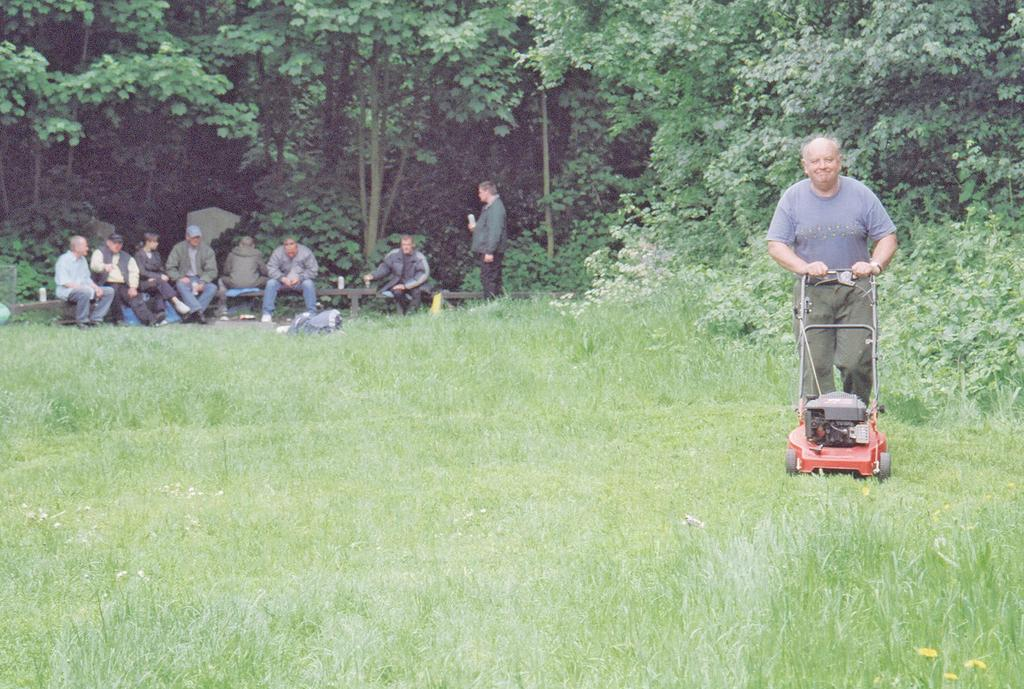How many people are in the image? There are people in the image, but the exact number is not specified. What is one person doing in the image? One person is holding a machine in the image. What can be seen under the people's feet? The ground is visible in the image, and there is grass on the ground. What type of vegetation is present in the image? There are plants and trees in the image. What type of light can be seen reflecting off the ducks in the image? There are no ducks present in the image, so there is no light reflecting off them. What type of smile is on the person's face in the image? The facts provided do not mention any facial expressions, so we cannot determine if there is a smile on the person's face. 